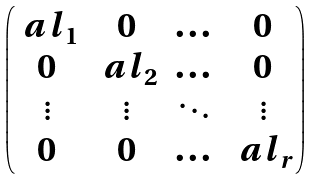Convert formula to latex. <formula><loc_0><loc_0><loc_500><loc_500>\begin{pmatrix} \ a l _ { 1 } & 0 & \dots & 0 \\ 0 & \ a l _ { 2 } & \dots & 0 \\ \vdots & \vdots & \ddots & \vdots \\ 0 & 0 & \dots & \ a l _ { r } \end{pmatrix}</formula> 